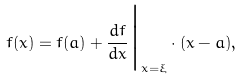Convert formula to latex. <formula><loc_0><loc_0><loc_500><loc_500>f ( x ) = f ( a ) + \frac { d f } { d x } \Big | _ { x = \xi } \cdot ( x - a ) ,</formula> 